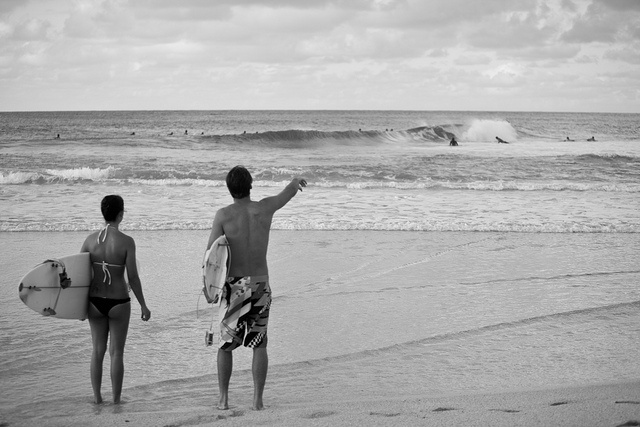Describe the objects in this image and their specific colors. I can see people in darkgray, gray, black, and lightgray tones, people in darkgray, black, gray, and lightgray tones, surfboard in darkgray, dimgray, gray, black, and lightgray tones, surfboard in darkgray, gray, lightgray, and black tones, and people in gray, black, and darkgray tones in this image. 